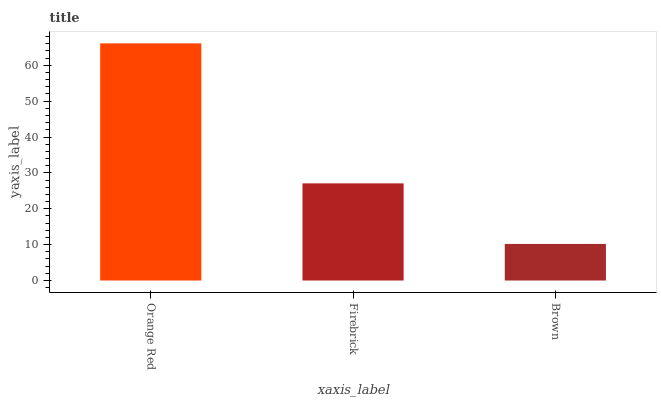Is Brown the minimum?
Answer yes or no. Yes. Is Orange Red the maximum?
Answer yes or no. Yes. Is Firebrick the minimum?
Answer yes or no. No. Is Firebrick the maximum?
Answer yes or no. No. Is Orange Red greater than Firebrick?
Answer yes or no. Yes. Is Firebrick less than Orange Red?
Answer yes or no. Yes. Is Firebrick greater than Orange Red?
Answer yes or no. No. Is Orange Red less than Firebrick?
Answer yes or no. No. Is Firebrick the high median?
Answer yes or no. Yes. Is Firebrick the low median?
Answer yes or no. Yes. Is Brown the high median?
Answer yes or no. No. Is Orange Red the low median?
Answer yes or no. No. 